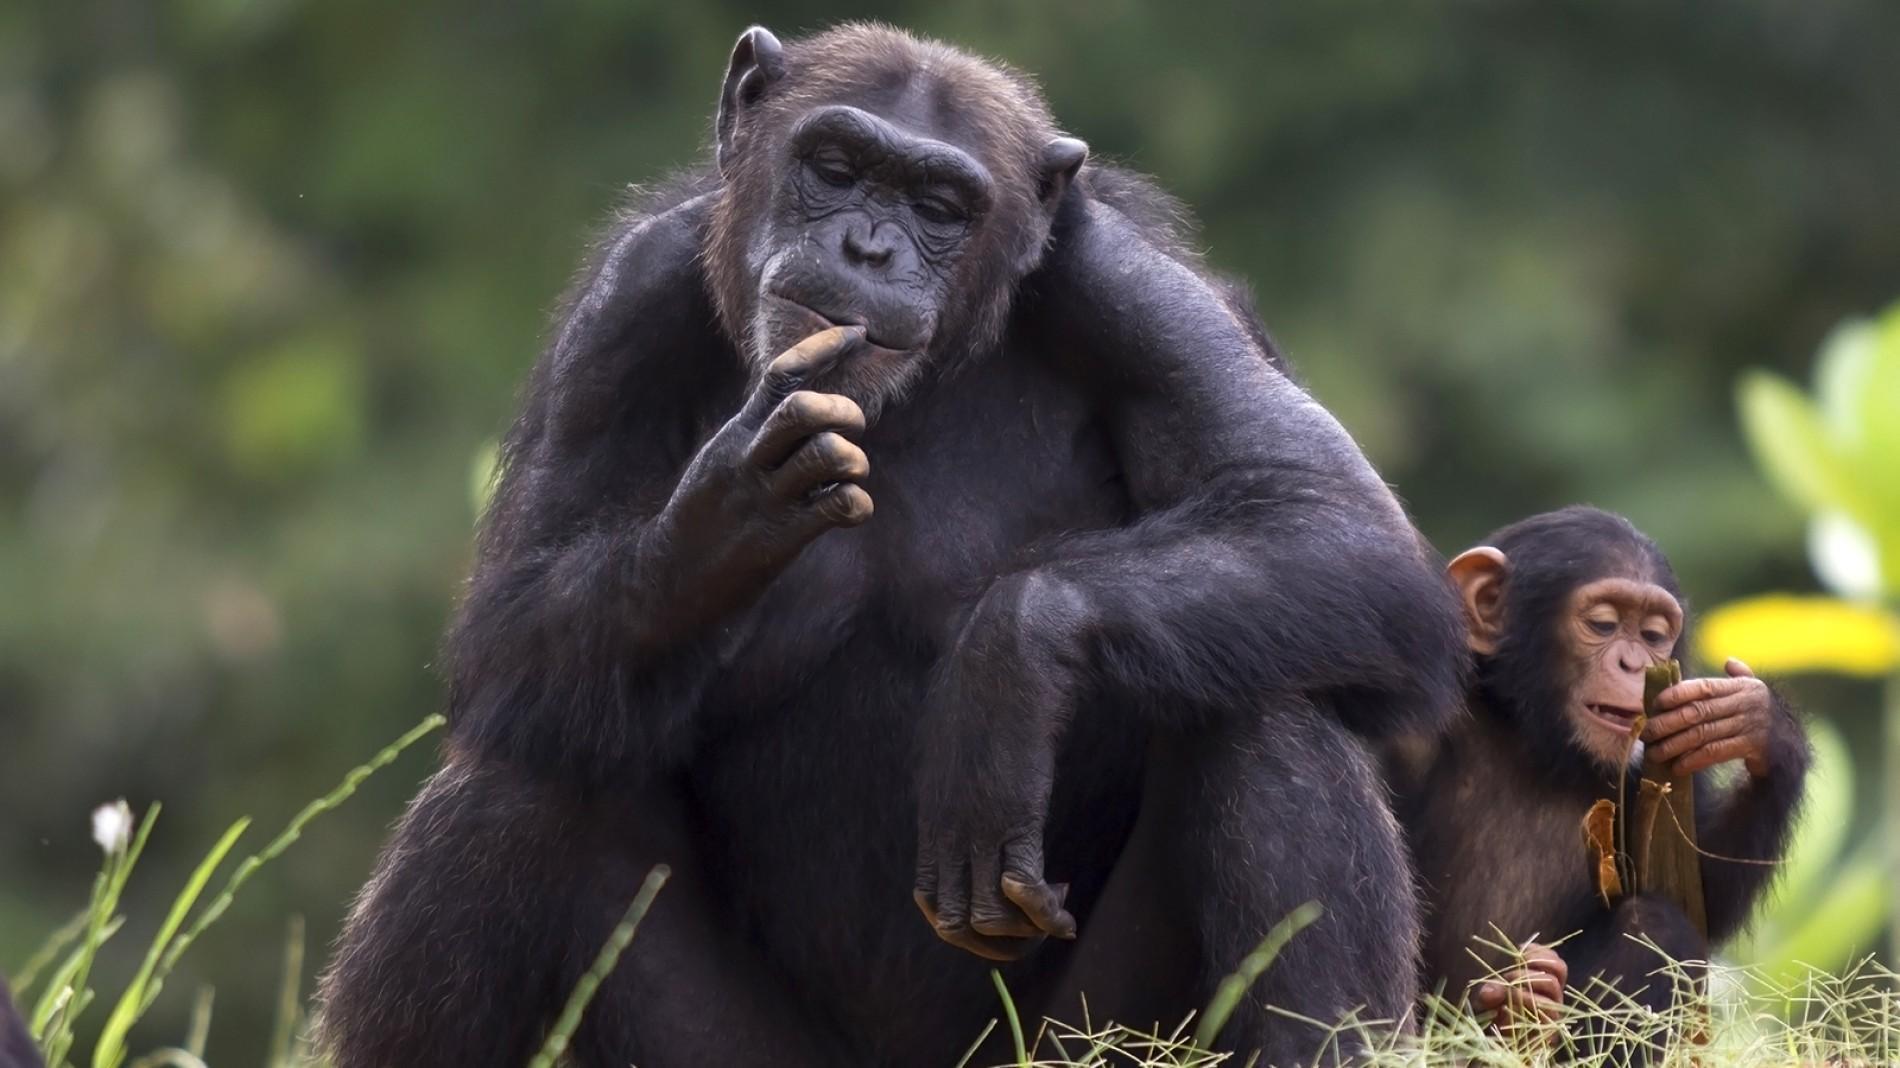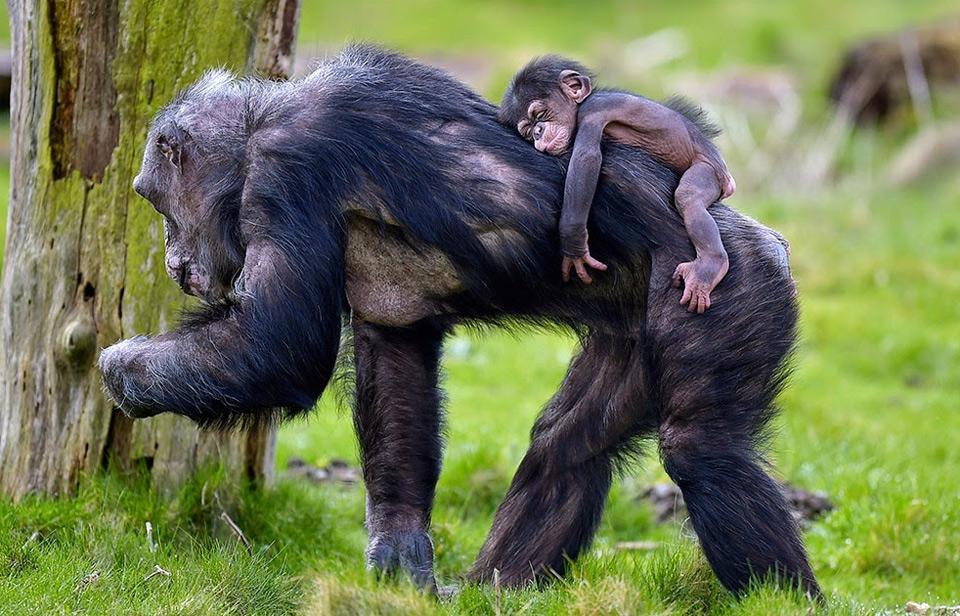The first image is the image on the left, the second image is the image on the right. Examine the images to the left and right. Is the description "There are four monkey-type animals including very young ones." accurate? Answer yes or no. Yes. 